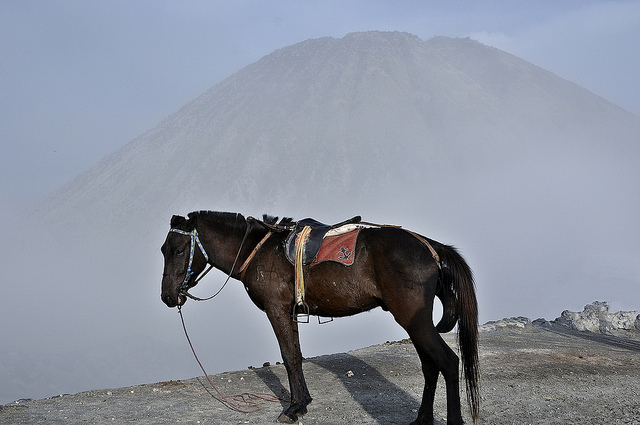How do the environmental conditions visible in this image potentially affect the horse? The foggy and possibly volcanic environment, as indicated by the obscured mountain in the background, can pose challenges for the horse, such as respiratory issues from volcanic ash or difficulty in maintaining footing on loose, ashy soil. 